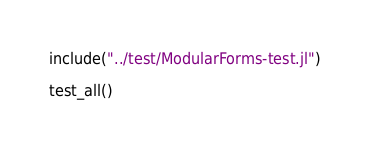Convert code to text. <code><loc_0><loc_0><loc_500><loc_500><_Julia_>
include("../test/ModularForms-test.jl")

test_all()
</code> 